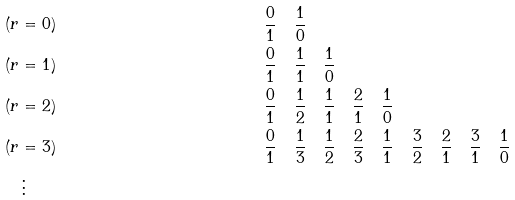Convert formula to latex. <formula><loc_0><loc_0><loc_500><loc_500>& ( r = 0 ) & \quad & \frac { 0 } { 1 } \quad \frac { 1 } { 0 } \\ & ( r = 1 ) & \quad & \frac { 0 } { 1 } \quad \frac { 1 } { 1 } \quad \frac { 1 } { 0 } \\ & ( r = 2 ) & \quad & \frac { 0 } { 1 } \quad \frac { 1 } { 2 } \quad \frac { 1 } { 1 } \quad \frac { 2 } { 1 } \quad \frac { 1 } { 0 } \\ & ( r = 3 ) & \quad & \frac { 0 } { 1 } \quad \frac { 1 } { 3 } \quad \frac { 1 } { 2 } \quad \frac { 2 } { 3 } \quad \frac { 1 } { 1 } \quad \frac { 3 } { 2 } \quad \frac { 2 } { 1 } \quad \frac { 3 } { 1 } \quad \frac { 1 } { 0 } \\ & \quad \vdots \\</formula> 